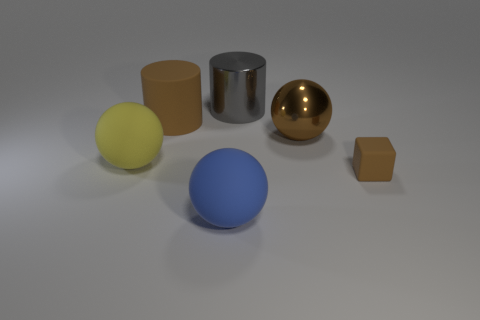Add 4 yellow matte balls. How many objects exist? 10 Subtract all cubes. How many objects are left? 5 Add 3 blue things. How many blue things are left? 4 Add 3 cyan things. How many cyan things exist? 3 Subtract 0 cyan balls. How many objects are left? 6 Subtract all red metallic cylinders. Subtract all large brown rubber cylinders. How many objects are left? 5 